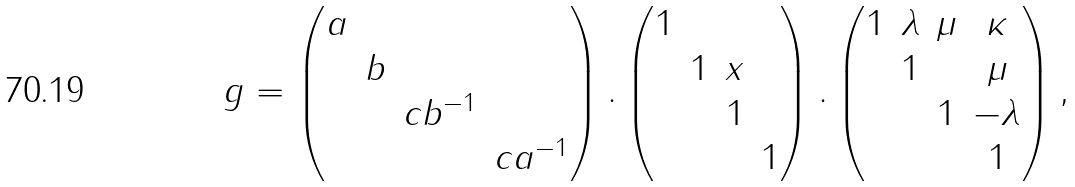Convert formula to latex. <formula><loc_0><loc_0><loc_500><loc_500>g = \begin{pmatrix} a & & & \\ & b & & \\ & & c b ^ { - 1 } & \\ & & & c a ^ { - 1 } \\ \end{pmatrix} . \begin{pmatrix} 1 & & & \\ & 1 & x & \\ & & 1 & \\ & & & 1 \\ \end{pmatrix} . \begin{pmatrix} 1 & \lambda & \mu & \kappa \\ & 1 & & \mu \\ & & 1 & - \lambda \\ & & & 1 \\ \end{pmatrix} ,</formula> 